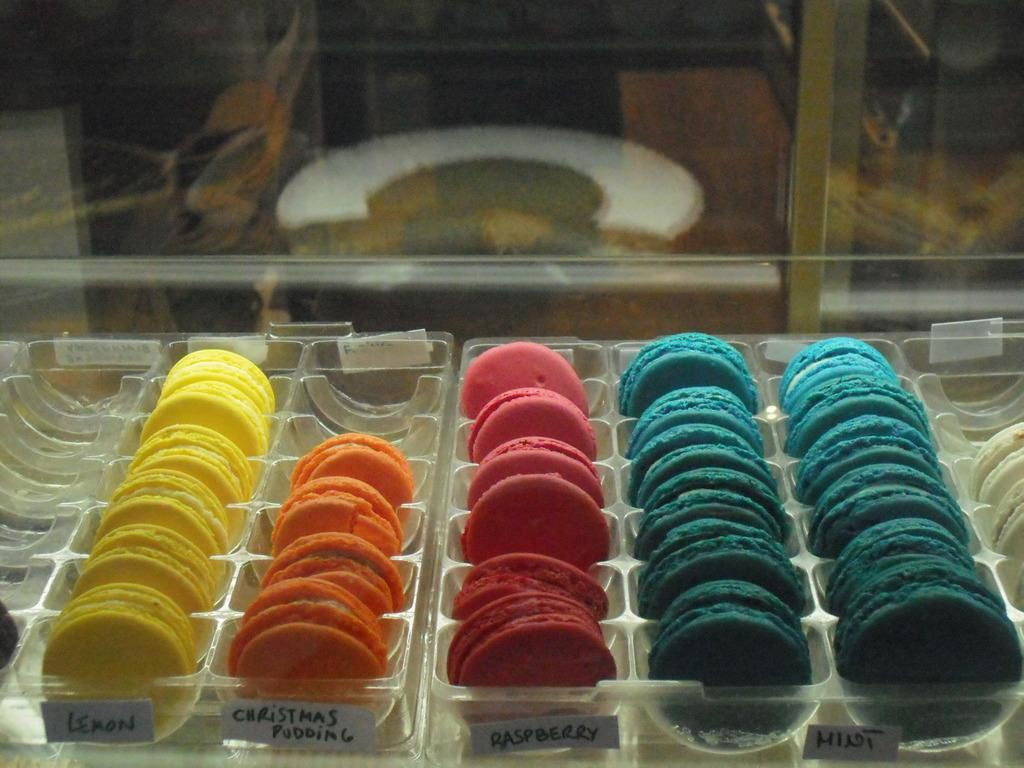Provide a one-sentence caption for the provided image. macarons cookie at store display in various flavors. 